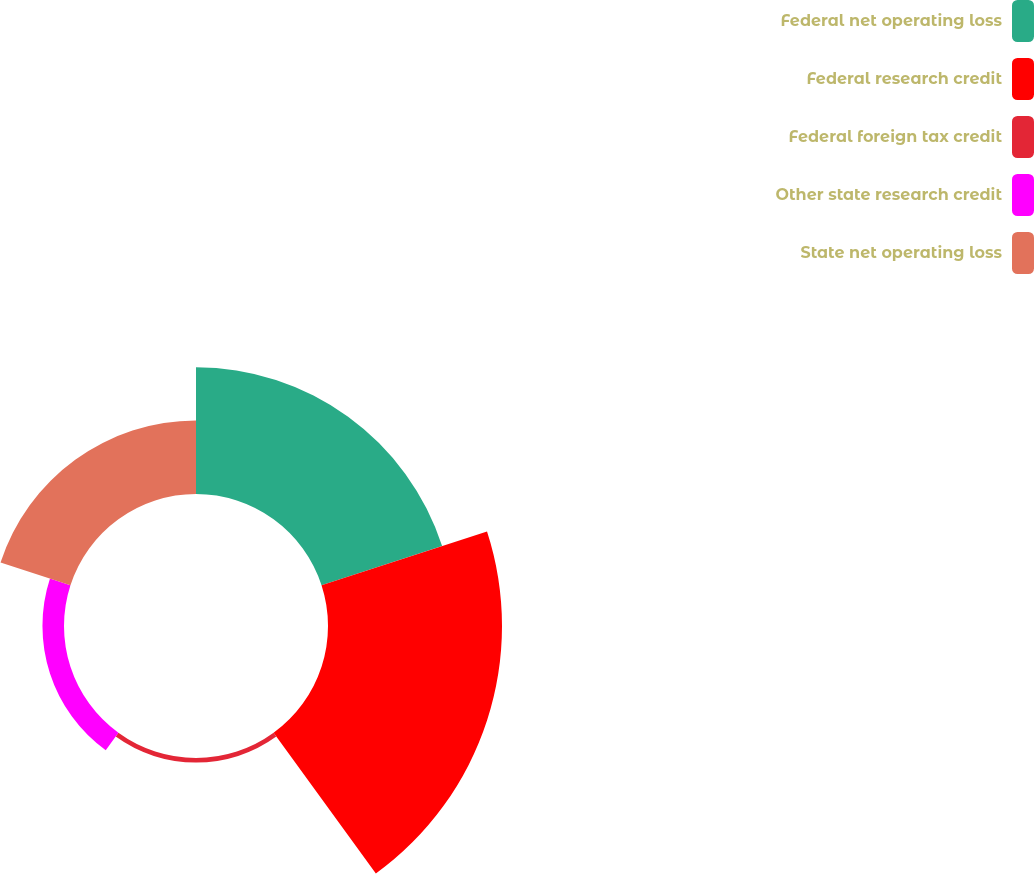<chart> <loc_0><loc_0><loc_500><loc_500><pie_chart><fcel>Federal net operating loss<fcel>Federal research credit<fcel>Federal foreign tax credit<fcel>Other state research credit<fcel>State net operating loss<nl><fcel>31.66%<fcel>43.45%<fcel>1.15%<fcel>5.38%<fcel>18.36%<nl></chart> 